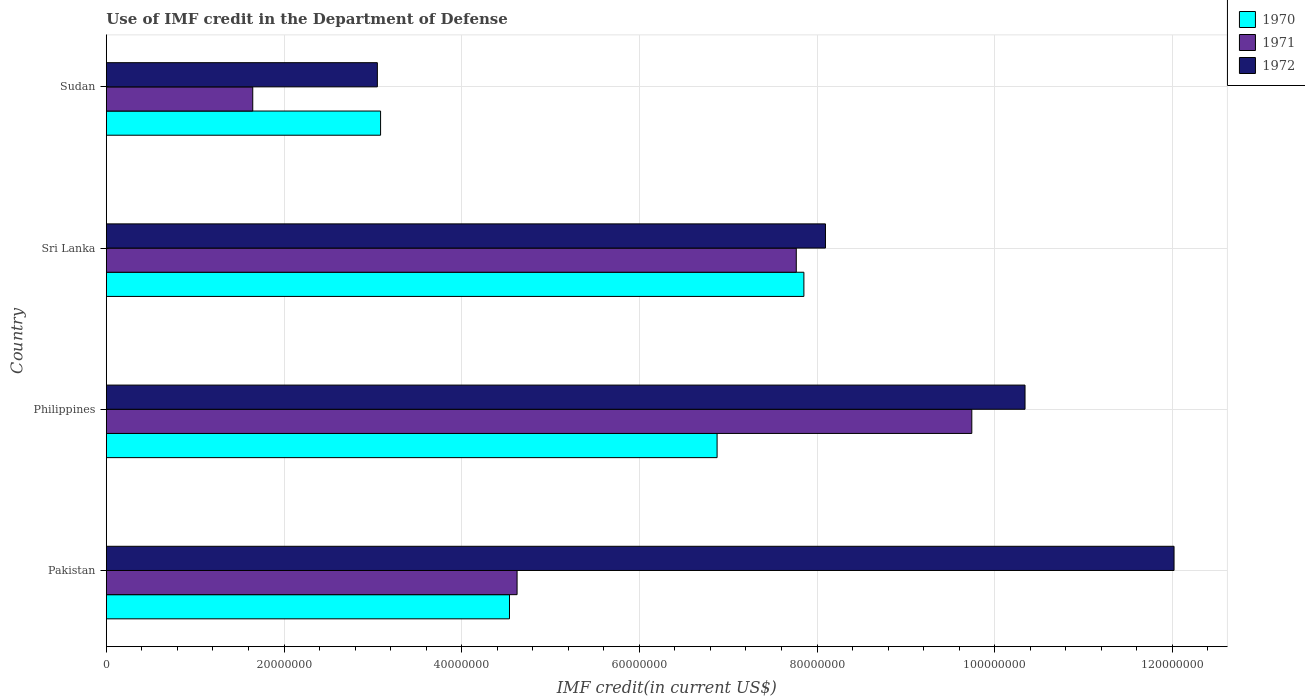How many groups of bars are there?
Your answer should be very brief. 4. Are the number of bars on each tick of the Y-axis equal?
Your response must be concise. Yes. How many bars are there on the 4th tick from the bottom?
Make the answer very short. 3. What is the IMF credit in the Department of Defense in 1970 in Pakistan?
Give a very brief answer. 4.54e+07. Across all countries, what is the maximum IMF credit in the Department of Defense in 1970?
Your answer should be compact. 7.85e+07. Across all countries, what is the minimum IMF credit in the Department of Defense in 1972?
Ensure brevity in your answer.  3.05e+07. In which country was the IMF credit in the Department of Defense in 1970 minimum?
Provide a short and direct response. Sudan. What is the total IMF credit in the Department of Defense in 1970 in the graph?
Make the answer very short. 2.24e+08. What is the difference between the IMF credit in the Department of Defense in 1971 in Pakistan and that in Philippines?
Offer a very short reply. -5.12e+07. What is the difference between the IMF credit in the Department of Defense in 1970 in Sri Lanka and the IMF credit in the Department of Defense in 1972 in Sudan?
Offer a terse response. 4.80e+07. What is the average IMF credit in the Department of Defense in 1972 per country?
Offer a very short reply. 8.38e+07. What is the difference between the IMF credit in the Department of Defense in 1972 and IMF credit in the Department of Defense in 1971 in Pakistan?
Make the answer very short. 7.40e+07. What is the ratio of the IMF credit in the Department of Defense in 1972 in Pakistan to that in Sudan?
Your answer should be very brief. 3.94. Is the difference between the IMF credit in the Department of Defense in 1972 in Philippines and Sudan greater than the difference between the IMF credit in the Department of Defense in 1971 in Philippines and Sudan?
Make the answer very short. No. What is the difference between the highest and the second highest IMF credit in the Department of Defense in 1970?
Offer a very short reply. 9.77e+06. What is the difference between the highest and the lowest IMF credit in the Department of Defense in 1970?
Offer a terse response. 4.76e+07. In how many countries, is the IMF credit in the Department of Defense in 1970 greater than the average IMF credit in the Department of Defense in 1970 taken over all countries?
Provide a succinct answer. 2. Is the sum of the IMF credit in the Department of Defense in 1972 in Sri Lanka and Sudan greater than the maximum IMF credit in the Department of Defense in 1970 across all countries?
Give a very brief answer. Yes. Is it the case that in every country, the sum of the IMF credit in the Department of Defense in 1972 and IMF credit in the Department of Defense in 1970 is greater than the IMF credit in the Department of Defense in 1971?
Keep it short and to the point. Yes. Are all the bars in the graph horizontal?
Ensure brevity in your answer.  Yes. What is the difference between two consecutive major ticks on the X-axis?
Make the answer very short. 2.00e+07. Are the values on the major ticks of X-axis written in scientific E-notation?
Your answer should be very brief. No. Does the graph contain any zero values?
Your answer should be very brief. No. Does the graph contain grids?
Give a very brief answer. Yes. Where does the legend appear in the graph?
Your answer should be very brief. Top right. How are the legend labels stacked?
Ensure brevity in your answer.  Vertical. What is the title of the graph?
Provide a succinct answer. Use of IMF credit in the Department of Defense. Does "2014" appear as one of the legend labels in the graph?
Your answer should be very brief. No. What is the label or title of the X-axis?
Your answer should be very brief. IMF credit(in current US$). What is the label or title of the Y-axis?
Your answer should be compact. Country. What is the IMF credit(in current US$) in 1970 in Pakistan?
Your answer should be very brief. 4.54e+07. What is the IMF credit(in current US$) in 1971 in Pakistan?
Ensure brevity in your answer.  4.62e+07. What is the IMF credit(in current US$) of 1972 in Pakistan?
Your response must be concise. 1.20e+08. What is the IMF credit(in current US$) of 1970 in Philippines?
Provide a short and direct response. 6.88e+07. What is the IMF credit(in current US$) in 1971 in Philippines?
Make the answer very short. 9.74e+07. What is the IMF credit(in current US$) of 1972 in Philippines?
Offer a very short reply. 1.03e+08. What is the IMF credit(in current US$) in 1970 in Sri Lanka?
Offer a very short reply. 7.85e+07. What is the IMF credit(in current US$) of 1971 in Sri Lanka?
Provide a short and direct response. 7.77e+07. What is the IMF credit(in current US$) in 1972 in Sri Lanka?
Your answer should be very brief. 8.10e+07. What is the IMF credit(in current US$) in 1970 in Sudan?
Offer a terse response. 3.09e+07. What is the IMF credit(in current US$) in 1971 in Sudan?
Your answer should be compact. 1.65e+07. What is the IMF credit(in current US$) in 1972 in Sudan?
Provide a short and direct response. 3.05e+07. Across all countries, what is the maximum IMF credit(in current US$) of 1970?
Your response must be concise. 7.85e+07. Across all countries, what is the maximum IMF credit(in current US$) of 1971?
Your answer should be very brief. 9.74e+07. Across all countries, what is the maximum IMF credit(in current US$) of 1972?
Ensure brevity in your answer.  1.20e+08. Across all countries, what is the minimum IMF credit(in current US$) of 1970?
Make the answer very short. 3.09e+07. Across all countries, what is the minimum IMF credit(in current US$) of 1971?
Keep it short and to the point. 1.65e+07. Across all countries, what is the minimum IMF credit(in current US$) of 1972?
Your answer should be compact. 3.05e+07. What is the total IMF credit(in current US$) in 1970 in the graph?
Offer a very short reply. 2.24e+08. What is the total IMF credit(in current US$) of 1971 in the graph?
Give a very brief answer. 2.38e+08. What is the total IMF credit(in current US$) of 1972 in the graph?
Ensure brevity in your answer.  3.35e+08. What is the difference between the IMF credit(in current US$) in 1970 in Pakistan and that in Philippines?
Provide a short and direct response. -2.34e+07. What is the difference between the IMF credit(in current US$) in 1971 in Pakistan and that in Philippines?
Offer a terse response. -5.12e+07. What is the difference between the IMF credit(in current US$) of 1972 in Pakistan and that in Philippines?
Your answer should be compact. 1.68e+07. What is the difference between the IMF credit(in current US$) in 1970 in Pakistan and that in Sri Lanka?
Provide a succinct answer. -3.31e+07. What is the difference between the IMF credit(in current US$) of 1971 in Pakistan and that in Sri Lanka?
Give a very brief answer. -3.14e+07. What is the difference between the IMF credit(in current US$) in 1972 in Pakistan and that in Sri Lanka?
Your answer should be compact. 3.92e+07. What is the difference between the IMF credit(in current US$) in 1970 in Pakistan and that in Sudan?
Your answer should be compact. 1.45e+07. What is the difference between the IMF credit(in current US$) in 1971 in Pakistan and that in Sudan?
Make the answer very short. 2.98e+07. What is the difference between the IMF credit(in current US$) in 1972 in Pakistan and that in Sudan?
Provide a short and direct response. 8.97e+07. What is the difference between the IMF credit(in current US$) in 1970 in Philippines and that in Sri Lanka?
Your answer should be compact. -9.77e+06. What is the difference between the IMF credit(in current US$) of 1971 in Philippines and that in Sri Lanka?
Offer a very short reply. 1.98e+07. What is the difference between the IMF credit(in current US$) of 1972 in Philippines and that in Sri Lanka?
Your answer should be compact. 2.25e+07. What is the difference between the IMF credit(in current US$) in 1970 in Philippines and that in Sudan?
Your answer should be compact. 3.79e+07. What is the difference between the IMF credit(in current US$) of 1971 in Philippines and that in Sudan?
Keep it short and to the point. 8.09e+07. What is the difference between the IMF credit(in current US$) in 1972 in Philippines and that in Sudan?
Ensure brevity in your answer.  7.29e+07. What is the difference between the IMF credit(in current US$) in 1970 in Sri Lanka and that in Sudan?
Your response must be concise. 4.76e+07. What is the difference between the IMF credit(in current US$) of 1971 in Sri Lanka and that in Sudan?
Offer a terse response. 6.12e+07. What is the difference between the IMF credit(in current US$) in 1972 in Sri Lanka and that in Sudan?
Offer a very short reply. 5.04e+07. What is the difference between the IMF credit(in current US$) in 1970 in Pakistan and the IMF credit(in current US$) in 1971 in Philippines?
Make the answer very short. -5.20e+07. What is the difference between the IMF credit(in current US$) in 1970 in Pakistan and the IMF credit(in current US$) in 1972 in Philippines?
Give a very brief answer. -5.80e+07. What is the difference between the IMF credit(in current US$) of 1971 in Pakistan and the IMF credit(in current US$) of 1972 in Philippines?
Ensure brevity in your answer.  -5.72e+07. What is the difference between the IMF credit(in current US$) in 1970 in Pakistan and the IMF credit(in current US$) in 1971 in Sri Lanka?
Provide a succinct answer. -3.23e+07. What is the difference between the IMF credit(in current US$) in 1970 in Pakistan and the IMF credit(in current US$) in 1972 in Sri Lanka?
Keep it short and to the point. -3.56e+07. What is the difference between the IMF credit(in current US$) in 1971 in Pakistan and the IMF credit(in current US$) in 1972 in Sri Lanka?
Offer a very short reply. -3.47e+07. What is the difference between the IMF credit(in current US$) in 1970 in Pakistan and the IMF credit(in current US$) in 1971 in Sudan?
Keep it short and to the point. 2.89e+07. What is the difference between the IMF credit(in current US$) of 1970 in Pakistan and the IMF credit(in current US$) of 1972 in Sudan?
Your response must be concise. 1.49e+07. What is the difference between the IMF credit(in current US$) of 1971 in Pakistan and the IMF credit(in current US$) of 1972 in Sudan?
Provide a succinct answer. 1.57e+07. What is the difference between the IMF credit(in current US$) in 1970 in Philippines and the IMF credit(in current US$) in 1971 in Sri Lanka?
Your answer should be very brief. -8.91e+06. What is the difference between the IMF credit(in current US$) of 1970 in Philippines and the IMF credit(in current US$) of 1972 in Sri Lanka?
Keep it short and to the point. -1.22e+07. What is the difference between the IMF credit(in current US$) of 1971 in Philippines and the IMF credit(in current US$) of 1972 in Sri Lanka?
Provide a succinct answer. 1.65e+07. What is the difference between the IMF credit(in current US$) of 1970 in Philippines and the IMF credit(in current US$) of 1971 in Sudan?
Your answer should be compact. 5.23e+07. What is the difference between the IMF credit(in current US$) in 1970 in Philippines and the IMF credit(in current US$) in 1972 in Sudan?
Ensure brevity in your answer.  3.82e+07. What is the difference between the IMF credit(in current US$) of 1971 in Philippines and the IMF credit(in current US$) of 1972 in Sudan?
Offer a very short reply. 6.69e+07. What is the difference between the IMF credit(in current US$) of 1970 in Sri Lanka and the IMF credit(in current US$) of 1971 in Sudan?
Your answer should be compact. 6.20e+07. What is the difference between the IMF credit(in current US$) in 1970 in Sri Lanka and the IMF credit(in current US$) in 1972 in Sudan?
Your answer should be very brief. 4.80e+07. What is the difference between the IMF credit(in current US$) of 1971 in Sri Lanka and the IMF credit(in current US$) of 1972 in Sudan?
Your response must be concise. 4.72e+07. What is the average IMF credit(in current US$) of 1970 per country?
Offer a very short reply. 5.59e+07. What is the average IMF credit(in current US$) in 1971 per country?
Provide a short and direct response. 5.95e+07. What is the average IMF credit(in current US$) in 1972 per country?
Offer a very short reply. 8.38e+07. What is the difference between the IMF credit(in current US$) of 1970 and IMF credit(in current US$) of 1971 in Pakistan?
Your answer should be compact. -8.56e+05. What is the difference between the IMF credit(in current US$) of 1970 and IMF credit(in current US$) of 1972 in Pakistan?
Your response must be concise. -7.48e+07. What is the difference between the IMF credit(in current US$) of 1971 and IMF credit(in current US$) of 1972 in Pakistan?
Ensure brevity in your answer.  -7.40e+07. What is the difference between the IMF credit(in current US$) in 1970 and IMF credit(in current US$) in 1971 in Philippines?
Your response must be concise. -2.87e+07. What is the difference between the IMF credit(in current US$) of 1970 and IMF credit(in current US$) of 1972 in Philippines?
Your response must be concise. -3.47e+07. What is the difference between the IMF credit(in current US$) of 1971 and IMF credit(in current US$) of 1972 in Philippines?
Your answer should be very brief. -5.99e+06. What is the difference between the IMF credit(in current US$) of 1970 and IMF credit(in current US$) of 1971 in Sri Lanka?
Provide a succinct answer. 8.56e+05. What is the difference between the IMF credit(in current US$) of 1970 and IMF credit(in current US$) of 1972 in Sri Lanka?
Offer a very short reply. -2.43e+06. What is the difference between the IMF credit(in current US$) in 1971 and IMF credit(in current US$) in 1972 in Sri Lanka?
Your response must be concise. -3.29e+06. What is the difference between the IMF credit(in current US$) of 1970 and IMF credit(in current US$) of 1971 in Sudan?
Your answer should be compact. 1.44e+07. What is the difference between the IMF credit(in current US$) of 1970 and IMF credit(in current US$) of 1972 in Sudan?
Provide a succinct answer. 3.62e+05. What is the difference between the IMF credit(in current US$) in 1971 and IMF credit(in current US$) in 1972 in Sudan?
Your answer should be very brief. -1.40e+07. What is the ratio of the IMF credit(in current US$) of 1970 in Pakistan to that in Philippines?
Provide a short and direct response. 0.66. What is the ratio of the IMF credit(in current US$) in 1971 in Pakistan to that in Philippines?
Keep it short and to the point. 0.47. What is the ratio of the IMF credit(in current US$) of 1972 in Pakistan to that in Philippines?
Provide a short and direct response. 1.16. What is the ratio of the IMF credit(in current US$) of 1970 in Pakistan to that in Sri Lanka?
Your answer should be very brief. 0.58. What is the ratio of the IMF credit(in current US$) in 1971 in Pakistan to that in Sri Lanka?
Give a very brief answer. 0.6. What is the ratio of the IMF credit(in current US$) in 1972 in Pakistan to that in Sri Lanka?
Provide a succinct answer. 1.48. What is the ratio of the IMF credit(in current US$) in 1970 in Pakistan to that in Sudan?
Your answer should be compact. 1.47. What is the ratio of the IMF credit(in current US$) in 1971 in Pakistan to that in Sudan?
Make the answer very short. 2.81. What is the ratio of the IMF credit(in current US$) of 1972 in Pakistan to that in Sudan?
Keep it short and to the point. 3.94. What is the ratio of the IMF credit(in current US$) of 1970 in Philippines to that in Sri Lanka?
Make the answer very short. 0.88. What is the ratio of the IMF credit(in current US$) in 1971 in Philippines to that in Sri Lanka?
Offer a terse response. 1.25. What is the ratio of the IMF credit(in current US$) of 1972 in Philippines to that in Sri Lanka?
Offer a very short reply. 1.28. What is the ratio of the IMF credit(in current US$) of 1970 in Philippines to that in Sudan?
Your answer should be very brief. 2.23. What is the ratio of the IMF credit(in current US$) in 1971 in Philippines to that in Sudan?
Make the answer very short. 5.91. What is the ratio of the IMF credit(in current US$) of 1972 in Philippines to that in Sudan?
Provide a short and direct response. 3.39. What is the ratio of the IMF credit(in current US$) in 1970 in Sri Lanka to that in Sudan?
Keep it short and to the point. 2.54. What is the ratio of the IMF credit(in current US$) of 1971 in Sri Lanka to that in Sudan?
Make the answer very short. 4.71. What is the ratio of the IMF credit(in current US$) in 1972 in Sri Lanka to that in Sudan?
Offer a terse response. 2.65. What is the difference between the highest and the second highest IMF credit(in current US$) of 1970?
Give a very brief answer. 9.77e+06. What is the difference between the highest and the second highest IMF credit(in current US$) in 1971?
Your answer should be very brief. 1.98e+07. What is the difference between the highest and the second highest IMF credit(in current US$) in 1972?
Make the answer very short. 1.68e+07. What is the difference between the highest and the lowest IMF credit(in current US$) of 1970?
Your response must be concise. 4.76e+07. What is the difference between the highest and the lowest IMF credit(in current US$) in 1971?
Your answer should be very brief. 8.09e+07. What is the difference between the highest and the lowest IMF credit(in current US$) of 1972?
Your response must be concise. 8.97e+07. 